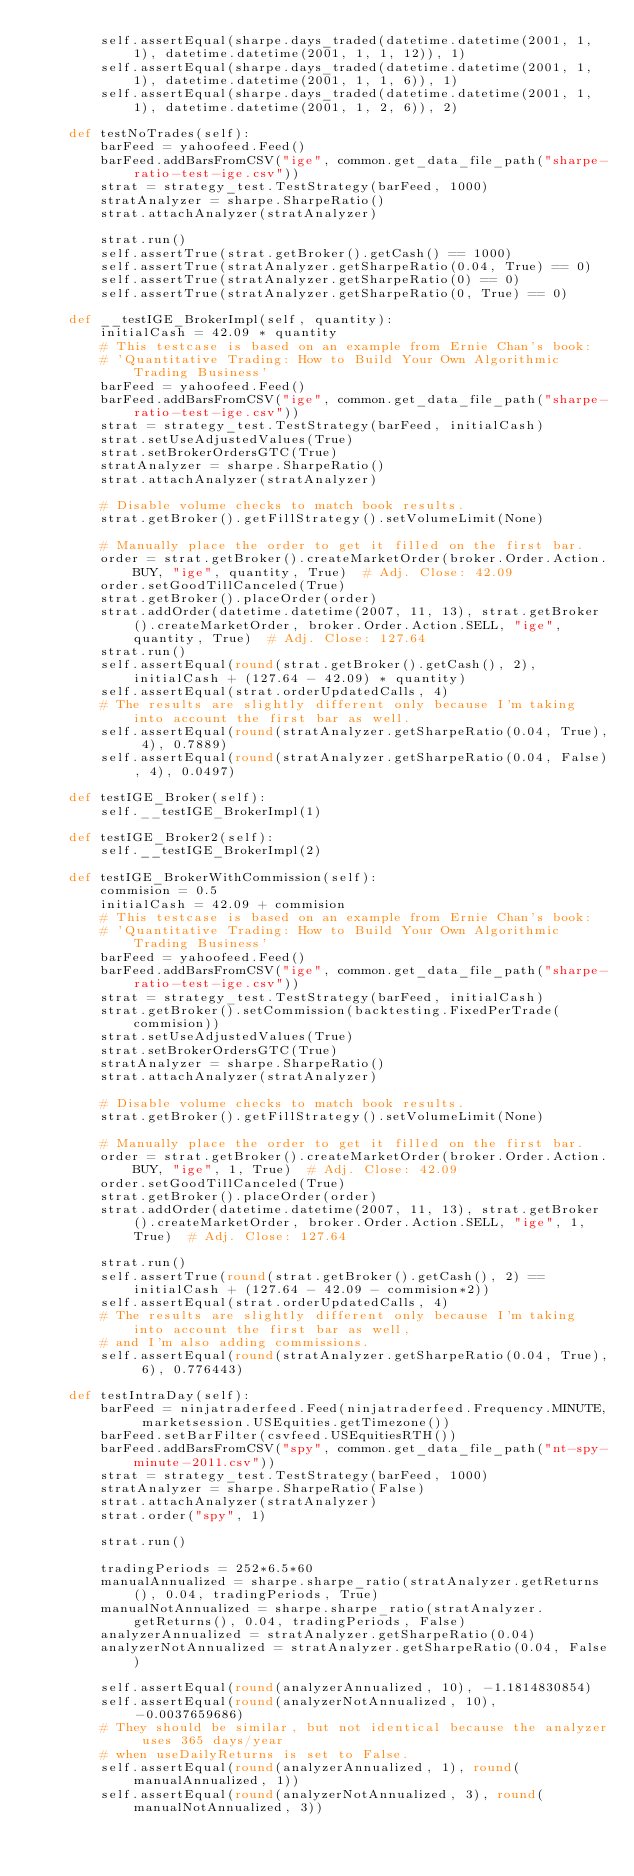<code> <loc_0><loc_0><loc_500><loc_500><_Python_>        self.assertEqual(sharpe.days_traded(datetime.datetime(2001, 1, 1), datetime.datetime(2001, 1, 1, 12)), 1)
        self.assertEqual(sharpe.days_traded(datetime.datetime(2001, 1, 1), datetime.datetime(2001, 1, 1, 6)), 1)
        self.assertEqual(sharpe.days_traded(datetime.datetime(2001, 1, 1), datetime.datetime(2001, 1, 2, 6)), 2)

    def testNoTrades(self):
        barFeed = yahoofeed.Feed()
        barFeed.addBarsFromCSV("ige", common.get_data_file_path("sharpe-ratio-test-ige.csv"))
        strat = strategy_test.TestStrategy(barFeed, 1000)
        stratAnalyzer = sharpe.SharpeRatio()
        strat.attachAnalyzer(stratAnalyzer)

        strat.run()
        self.assertTrue(strat.getBroker().getCash() == 1000)
        self.assertTrue(stratAnalyzer.getSharpeRatio(0.04, True) == 0)
        self.assertTrue(stratAnalyzer.getSharpeRatio(0) == 0)
        self.assertTrue(stratAnalyzer.getSharpeRatio(0, True) == 0)

    def __testIGE_BrokerImpl(self, quantity):
        initialCash = 42.09 * quantity
        # This testcase is based on an example from Ernie Chan's book:
        # 'Quantitative Trading: How to Build Your Own Algorithmic Trading Business'
        barFeed = yahoofeed.Feed()
        barFeed.addBarsFromCSV("ige", common.get_data_file_path("sharpe-ratio-test-ige.csv"))
        strat = strategy_test.TestStrategy(barFeed, initialCash)
        strat.setUseAdjustedValues(True)
        strat.setBrokerOrdersGTC(True)
        stratAnalyzer = sharpe.SharpeRatio()
        strat.attachAnalyzer(stratAnalyzer)

        # Disable volume checks to match book results.
        strat.getBroker().getFillStrategy().setVolumeLimit(None)

        # Manually place the order to get it filled on the first bar.
        order = strat.getBroker().createMarketOrder(broker.Order.Action.BUY, "ige", quantity, True)  # Adj. Close: 42.09
        order.setGoodTillCanceled(True)
        strat.getBroker().placeOrder(order)
        strat.addOrder(datetime.datetime(2007, 11, 13), strat.getBroker().createMarketOrder, broker.Order.Action.SELL, "ige", quantity, True)  # Adj. Close: 127.64
        strat.run()
        self.assertEqual(round(strat.getBroker().getCash(), 2), initialCash + (127.64 - 42.09) * quantity)
        self.assertEqual(strat.orderUpdatedCalls, 4)
        # The results are slightly different only because I'm taking into account the first bar as well.
        self.assertEqual(round(stratAnalyzer.getSharpeRatio(0.04, True), 4), 0.7889)
        self.assertEqual(round(stratAnalyzer.getSharpeRatio(0.04, False), 4), 0.0497)

    def testIGE_Broker(self):
        self.__testIGE_BrokerImpl(1)

    def testIGE_Broker2(self):
        self.__testIGE_BrokerImpl(2)

    def testIGE_BrokerWithCommission(self):
        commision = 0.5
        initialCash = 42.09 + commision
        # This testcase is based on an example from Ernie Chan's book:
        # 'Quantitative Trading: How to Build Your Own Algorithmic Trading Business'
        barFeed = yahoofeed.Feed()
        barFeed.addBarsFromCSV("ige", common.get_data_file_path("sharpe-ratio-test-ige.csv"))
        strat = strategy_test.TestStrategy(barFeed, initialCash)
        strat.getBroker().setCommission(backtesting.FixedPerTrade(commision))
        strat.setUseAdjustedValues(True)
        strat.setBrokerOrdersGTC(True)
        stratAnalyzer = sharpe.SharpeRatio()
        strat.attachAnalyzer(stratAnalyzer)

        # Disable volume checks to match book results.
        strat.getBroker().getFillStrategy().setVolumeLimit(None)

        # Manually place the order to get it filled on the first bar.
        order = strat.getBroker().createMarketOrder(broker.Order.Action.BUY, "ige", 1, True)  # Adj. Close: 42.09
        order.setGoodTillCanceled(True)
        strat.getBroker().placeOrder(order)
        strat.addOrder(datetime.datetime(2007, 11, 13), strat.getBroker().createMarketOrder, broker.Order.Action.SELL, "ige", 1, True)  # Adj. Close: 127.64

        strat.run()
        self.assertTrue(round(strat.getBroker().getCash(), 2) == initialCash + (127.64 - 42.09 - commision*2))
        self.assertEqual(strat.orderUpdatedCalls, 4)
        # The results are slightly different only because I'm taking into account the first bar as well,
        # and I'm also adding commissions.
        self.assertEqual(round(stratAnalyzer.getSharpeRatio(0.04, True), 6), 0.776443)

    def testIntraDay(self):
        barFeed = ninjatraderfeed.Feed(ninjatraderfeed.Frequency.MINUTE, marketsession.USEquities.getTimezone())
        barFeed.setBarFilter(csvfeed.USEquitiesRTH())
        barFeed.addBarsFromCSV("spy", common.get_data_file_path("nt-spy-minute-2011.csv"))
        strat = strategy_test.TestStrategy(barFeed, 1000)
        stratAnalyzer = sharpe.SharpeRatio(False)
        strat.attachAnalyzer(stratAnalyzer)
        strat.order("spy", 1)

        strat.run()

        tradingPeriods = 252*6.5*60
        manualAnnualized = sharpe.sharpe_ratio(stratAnalyzer.getReturns(), 0.04, tradingPeriods, True)
        manualNotAnnualized = sharpe.sharpe_ratio(stratAnalyzer.getReturns(), 0.04, tradingPeriods, False)
        analyzerAnnualized = stratAnalyzer.getSharpeRatio(0.04)
        analyzerNotAnnualized = stratAnalyzer.getSharpeRatio(0.04, False)

        self.assertEqual(round(analyzerAnnualized, 10), -1.1814830854)
        self.assertEqual(round(analyzerNotAnnualized, 10), -0.0037659686)
        # They should be similar, but not identical because the analyzer uses 365 days/year
        # when useDailyReturns is set to False.
        self.assertEqual(round(analyzerAnnualized, 1), round(manualAnnualized, 1))
        self.assertEqual(round(analyzerNotAnnualized, 3), round(manualNotAnnualized, 3))
</code> 